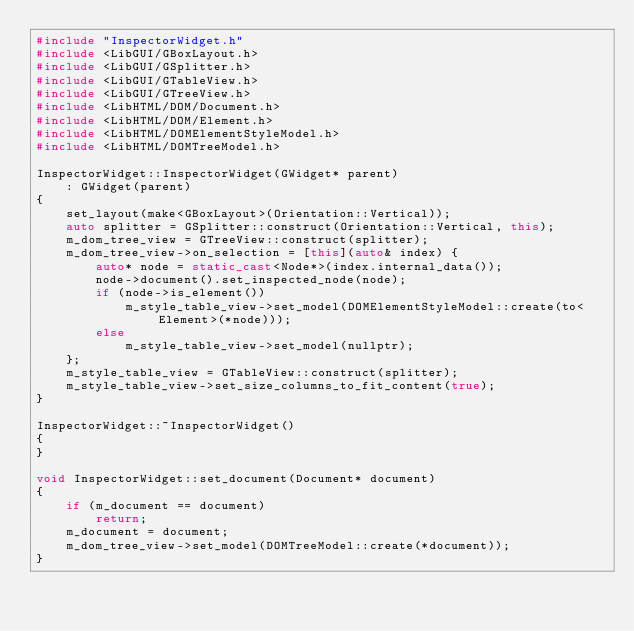Convert code to text. <code><loc_0><loc_0><loc_500><loc_500><_C++_>#include "InspectorWidget.h"
#include <LibGUI/GBoxLayout.h>
#include <LibGUI/GSplitter.h>
#include <LibGUI/GTableView.h>
#include <LibGUI/GTreeView.h>
#include <LibHTML/DOM/Document.h>
#include <LibHTML/DOM/Element.h>
#include <LibHTML/DOMElementStyleModel.h>
#include <LibHTML/DOMTreeModel.h>

InspectorWidget::InspectorWidget(GWidget* parent)
    : GWidget(parent)
{
    set_layout(make<GBoxLayout>(Orientation::Vertical));
    auto splitter = GSplitter::construct(Orientation::Vertical, this);
    m_dom_tree_view = GTreeView::construct(splitter);
    m_dom_tree_view->on_selection = [this](auto& index) {
        auto* node = static_cast<Node*>(index.internal_data());
        node->document().set_inspected_node(node);
        if (node->is_element())
            m_style_table_view->set_model(DOMElementStyleModel::create(to<Element>(*node)));
        else
            m_style_table_view->set_model(nullptr);
    };
    m_style_table_view = GTableView::construct(splitter);
    m_style_table_view->set_size_columns_to_fit_content(true);
}

InspectorWidget::~InspectorWidget()
{
}

void InspectorWidget::set_document(Document* document)
{
    if (m_document == document)
        return;
    m_document = document;
    m_dom_tree_view->set_model(DOMTreeModel::create(*document));
}
</code> 